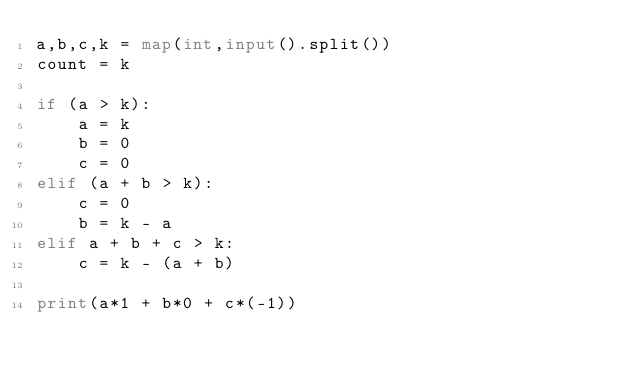Convert code to text. <code><loc_0><loc_0><loc_500><loc_500><_Python_>a,b,c,k = map(int,input().split())
count = k

if (a > k):
    a = k
    b = 0
    c = 0
elif (a + b > k):
    c = 0
    b = k - a 
elif a + b + c > k:
    c = k - (a + b)

print(a*1 + b*0 + c*(-1)) </code> 